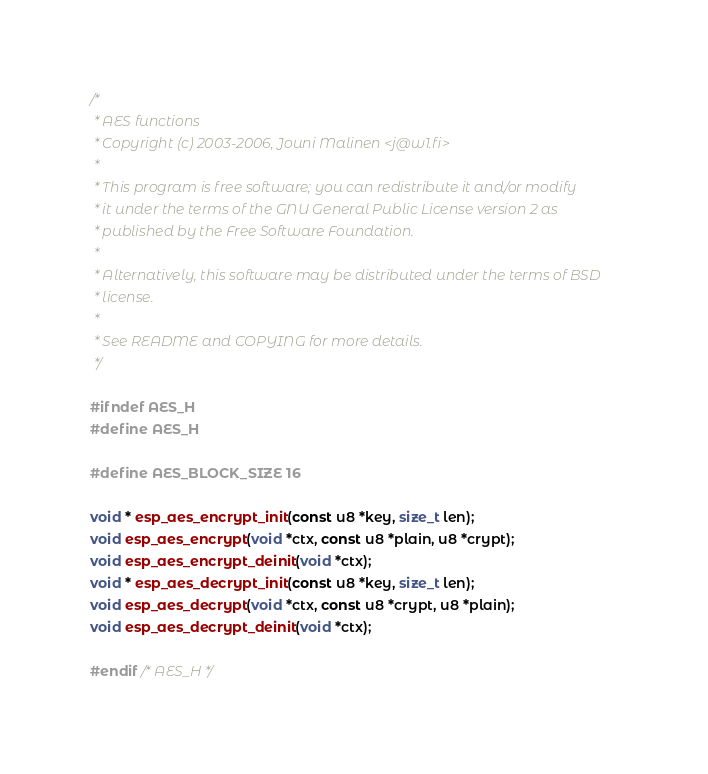Convert code to text. <code><loc_0><loc_0><loc_500><loc_500><_C_>/*
 * AES functions
 * Copyright (c) 2003-2006, Jouni Malinen <j@w1.fi>
 *
 * This program is free software; you can redistribute it and/or modify
 * it under the terms of the GNU General Public License version 2 as
 * published by the Free Software Foundation.
 *
 * Alternatively, this software may be distributed under the terms of BSD
 * license.
 *
 * See README and COPYING for more details.
 */

#ifndef AES_H
#define AES_H

#define AES_BLOCK_SIZE 16

void * esp_aes_encrypt_init(const u8 *key, size_t len);
void esp_aes_encrypt(void *ctx, const u8 *plain, u8 *crypt);
void esp_aes_encrypt_deinit(void *ctx);
void * esp_aes_decrypt_init(const u8 *key, size_t len);
void esp_aes_decrypt(void *ctx, const u8 *crypt, u8 *plain);
void esp_aes_decrypt_deinit(void *ctx);

#endif /* AES_H */
</code> 